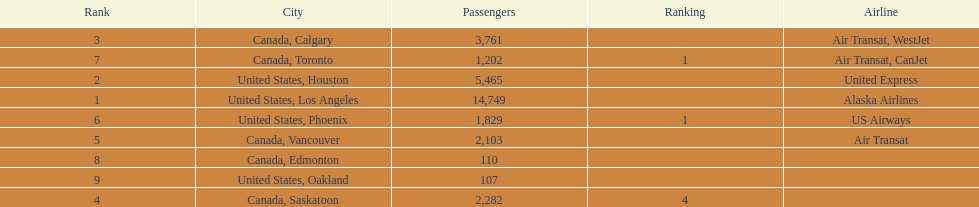How many cities from canada are on this list? 5. 